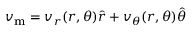Convert formula to latex. <formula><loc_0><loc_0><loc_500><loc_500>v _ { m } = v _ { r } ( r , \theta ) \hat { r } + v _ { \theta } ( r , \theta ) \hat { \theta }</formula> 